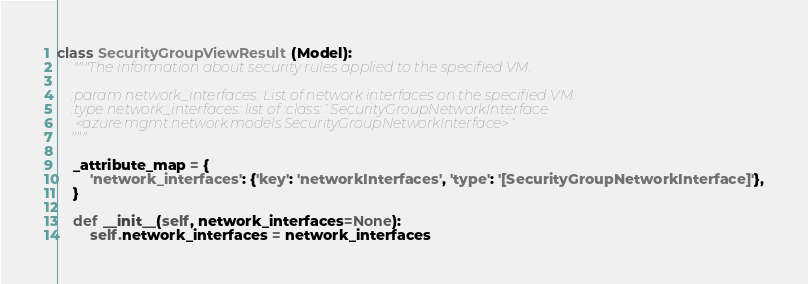<code> <loc_0><loc_0><loc_500><loc_500><_Python_>

class SecurityGroupViewResult(Model):
    """The information about security rules applied to the specified VM.

    :param network_interfaces: List of network interfaces on the specified VM.
    :type network_interfaces: list of :class:`SecurityGroupNetworkInterface
     <azure.mgmt.network.models.SecurityGroupNetworkInterface>`
    """

    _attribute_map = {
        'network_interfaces': {'key': 'networkInterfaces', 'type': '[SecurityGroupNetworkInterface]'},
    }

    def __init__(self, network_interfaces=None):
        self.network_interfaces = network_interfaces
</code> 